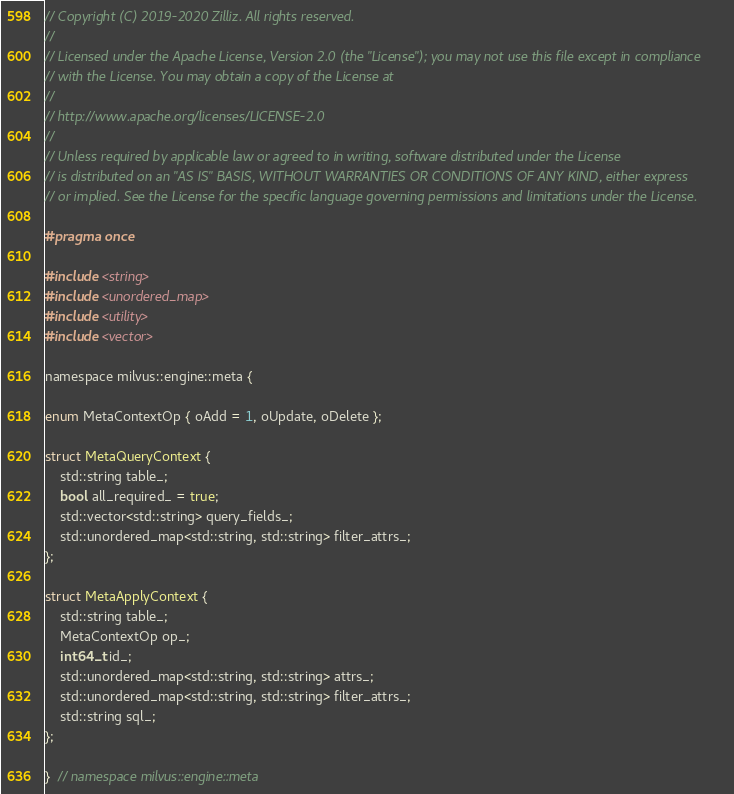Convert code to text. <code><loc_0><loc_0><loc_500><loc_500><_C_>// Copyright (C) 2019-2020 Zilliz. All rights reserved.
//
// Licensed under the Apache License, Version 2.0 (the "License"); you may not use this file except in compliance
// with the License. You may obtain a copy of the License at
//
// http://www.apache.org/licenses/LICENSE-2.0
//
// Unless required by applicable law or agreed to in writing, software distributed under the License
// is distributed on an "AS IS" BASIS, WITHOUT WARRANTIES OR CONDITIONS OF ANY KIND, either express
// or implied. See the License for the specific language governing permissions and limitations under the License.

#pragma once

#include <string>
#include <unordered_map>
#include <utility>
#include <vector>

namespace milvus::engine::meta {

enum MetaContextOp { oAdd = 1, oUpdate, oDelete };

struct MetaQueryContext {
    std::string table_;
    bool all_required_ = true;
    std::vector<std::string> query_fields_;
    std::unordered_map<std::string, std::string> filter_attrs_;
};

struct MetaApplyContext {
    std::string table_;
    MetaContextOp op_;
    int64_t id_;
    std::unordered_map<std::string, std::string> attrs_;
    std::unordered_map<std::string, std::string> filter_attrs_;
    std::string sql_;
};

}  // namespace milvus::engine::meta
</code> 